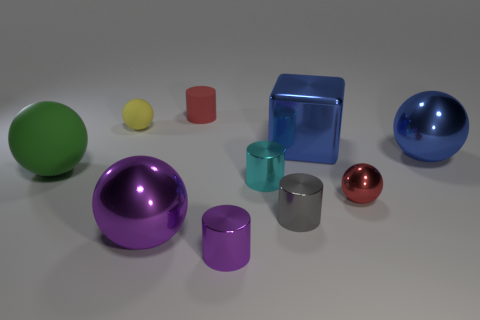What number of red things are the same size as the gray metallic cylinder?
Keep it short and to the point. 2. The blue metallic sphere is what size?
Provide a short and direct response. Large. There is a tiny yellow matte sphere; how many large objects are to the right of it?
Give a very brief answer. 3. There is a blue thing that is the same material as the large blue ball; what shape is it?
Give a very brief answer. Cube. Is the number of small purple metallic cylinders right of the small red ball less than the number of tiny red cylinders behind the big green object?
Offer a very short reply. Yes. Are there more large blue shiny cubes than cyan cubes?
Your answer should be very brief. Yes. What material is the blue block?
Offer a very short reply. Metal. What is the color of the big metallic sphere that is behind the green rubber ball?
Provide a short and direct response. Blue. Are there more rubber spheres in front of the large blue shiny cube than gray metal objects that are behind the cyan cylinder?
Ensure brevity in your answer.  Yes. What is the size of the purple object on the right side of the purple thing that is to the left of the tiny red object behind the small cyan metal cylinder?
Your response must be concise. Small. 